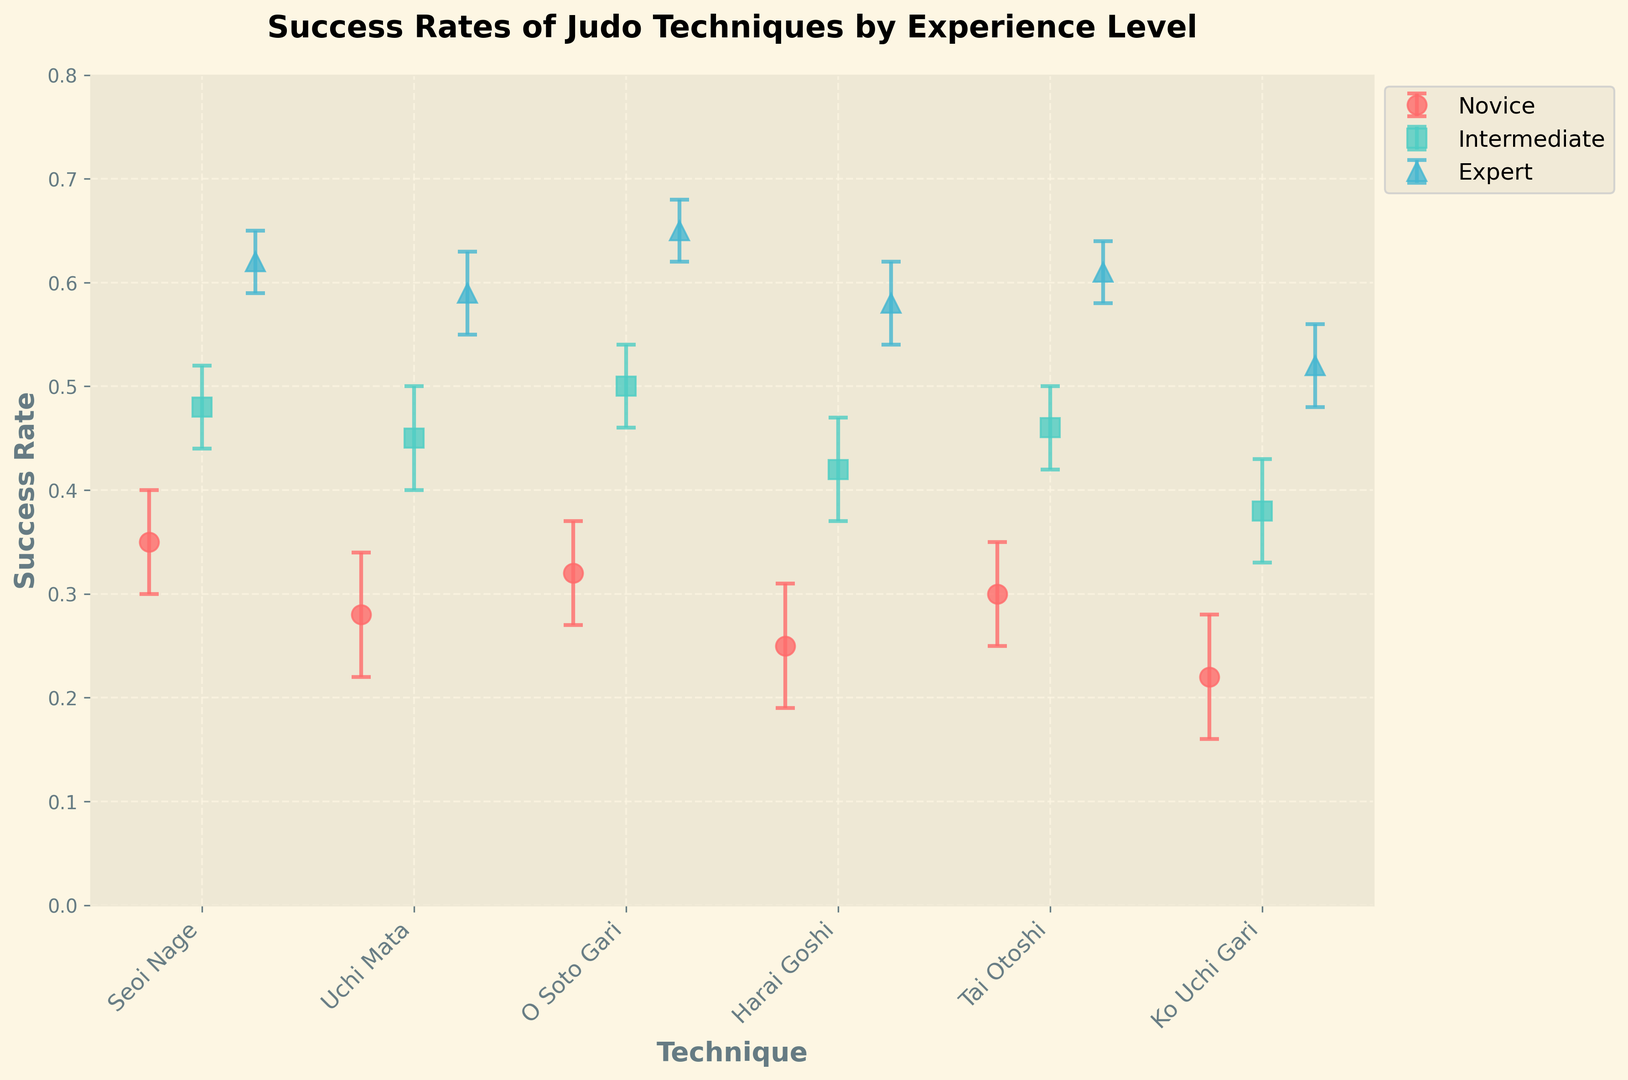Which technique has the highest success rate for Novice levels? Look at the error bars for Novice levels and identify the technique with the highest success rate. Seoi Nage has a success rate of 0.35, which is the highest among Novice levels.
Answer: Seoi Nage Among experts, how do Seoi Nage and O Soto Gari compare in terms of success rates? Compare the success rates of Seoi Nage (0.62) and O Soto Gari (0.65) for the Expert level by looking at their respective bars. O Soto Gari has a higher success rate than Seoi Nage.
Answer: O Soto Gari has a higher success rate What's the average success rate of Uchi Mata across all experience levels? Calculate the average by summing up the success rates for Uchi Mata (0.28 for Novice, 0.45 for Intermediate, and 0.59 for Expert) and dividing by the number of levels. The calculation is (0.28 + 0.45 + 0.59) / 3 = 1.32 / 3 = 0.44.
Answer: 0.44 What is the difference in success rates between Intermediate and Expert levels for Harai Goshi? Subtract the success rate of the Intermediate level (0.42) from the Expert level (0.58) for Harai Goshi. The calculation is 0.58 - 0.42 = 0.16.
Answer: 0.16 Which technique shows the greatest improvement in success rate from Novice to Expert? Look at the success rates for each technique and calculate the increase from Novice to Expert. Compare these values to find the largest one. For instance, Seoi Nage improves from 0.35 to 0.62, an increase of 0.27; similarly, compare for others, and O Soto Gari improves the most (from 0.32 to 0.65, an increase of 0.33).
Answer: O Soto Gari How does the range of success rates for Tai Otoshi vary across levels? Identify the maximum and minimum success rates for Tai Otoshi (0.61 for Expert, 0.46 for Intermediate, and 0.30 for Novice) and subtract the minimum from the maximum to find the range. The calculation is 0.61 - 0.30 = 0.31.
Answer: 0.31 Which experience level has the smallest range of success rates between techniques? Calculate the difference between the highest and lowest success rates for each experience level and compare these ranges. For Experts: the range is 0.65 (O Soto Gari) - 0.52 (Ko Uchi Gari) = 0.13; for Intermediates: 0.50 (O Soto Gari) - 0.38 (Ko Uchi Gari) = 0.12; for Novices: 0.35 (Seoi Nage) - 0.22 (Ko Uchi Gari) = 0.13.
Answer: Intermediate What can be inferred about the success rate trends as experience increases? Analyze the success rates for each technique across different experience levels. Generally, the success rates increase with experience for all techniques.
Answer: Success rates generally increase with experience Which technique has the least improvement in success rate from Novice to Expert? Calculate the increase in success rates from Novice to Expert for each technique. The smallest increase is for Ko Uchi Gari, which improves from 0.22 to 0.52 (an increase of 0.30). This is less significant compared to increases in other techniques.
Answer: Ko Uchi Gari 